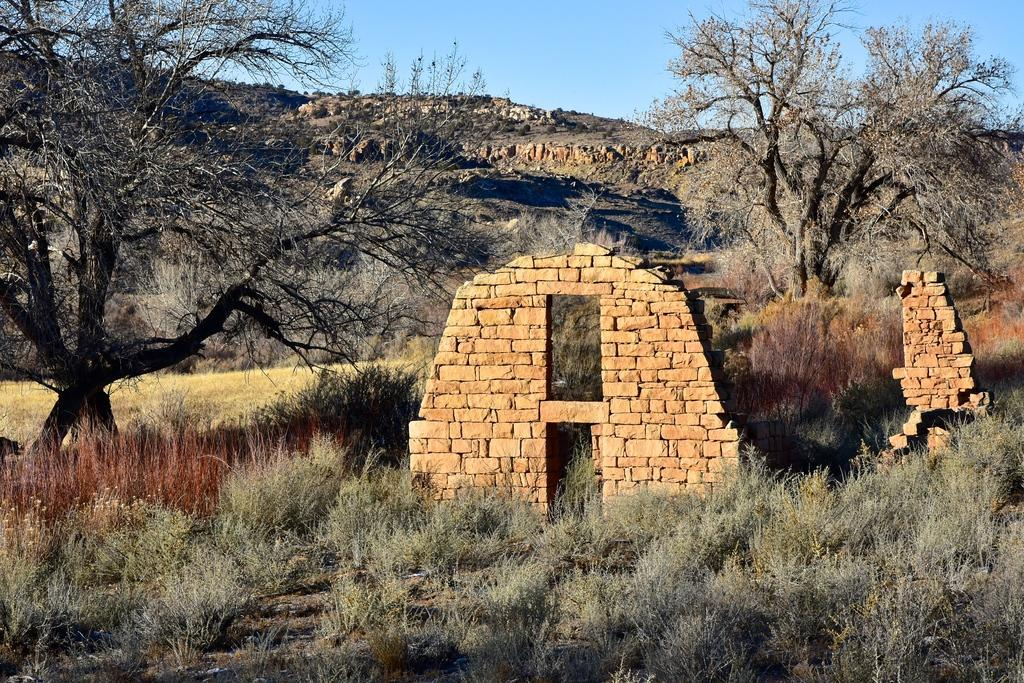What type of vegetation is present in the image? There is grass and trees in the image. What type of structure can be seen in the image? There is a wall in the image. What material is the wall made of? The wall is made of bricks. What can be seen in the background of the image? There is a hill and the sky visible in the background of the image. What type of acoustics can be heard from the yam in the image? There is no yam present in the image, and therefore no acoustics can be heard from it. 